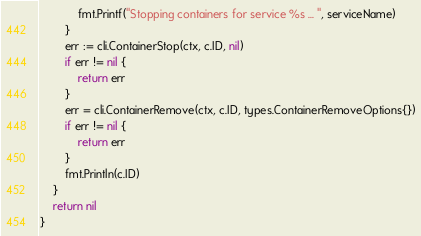Convert code to text. <code><loc_0><loc_0><loc_500><loc_500><_Go_>			fmt.Printf("Stopping containers for service %s ... ", serviceName)
		}
		err := cli.ContainerStop(ctx, c.ID, nil)
		if err != nil {
			return err
		}
		err = cli.ContainerRemove(ctx, c.ID, types.ContainerRemoveOptions{})
		if err != nil {
			return err
		}
		fmt.Println(c.ID)
	}
	return nil
}
</code> 